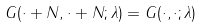Convert formula to latex. <formula><loc_0><loc_0><loc_500><loc_500>G ( \cdot + N , \cdot + N ; \lambda ) = G ( \cdot , \cdot ; \lambda )</formula> 